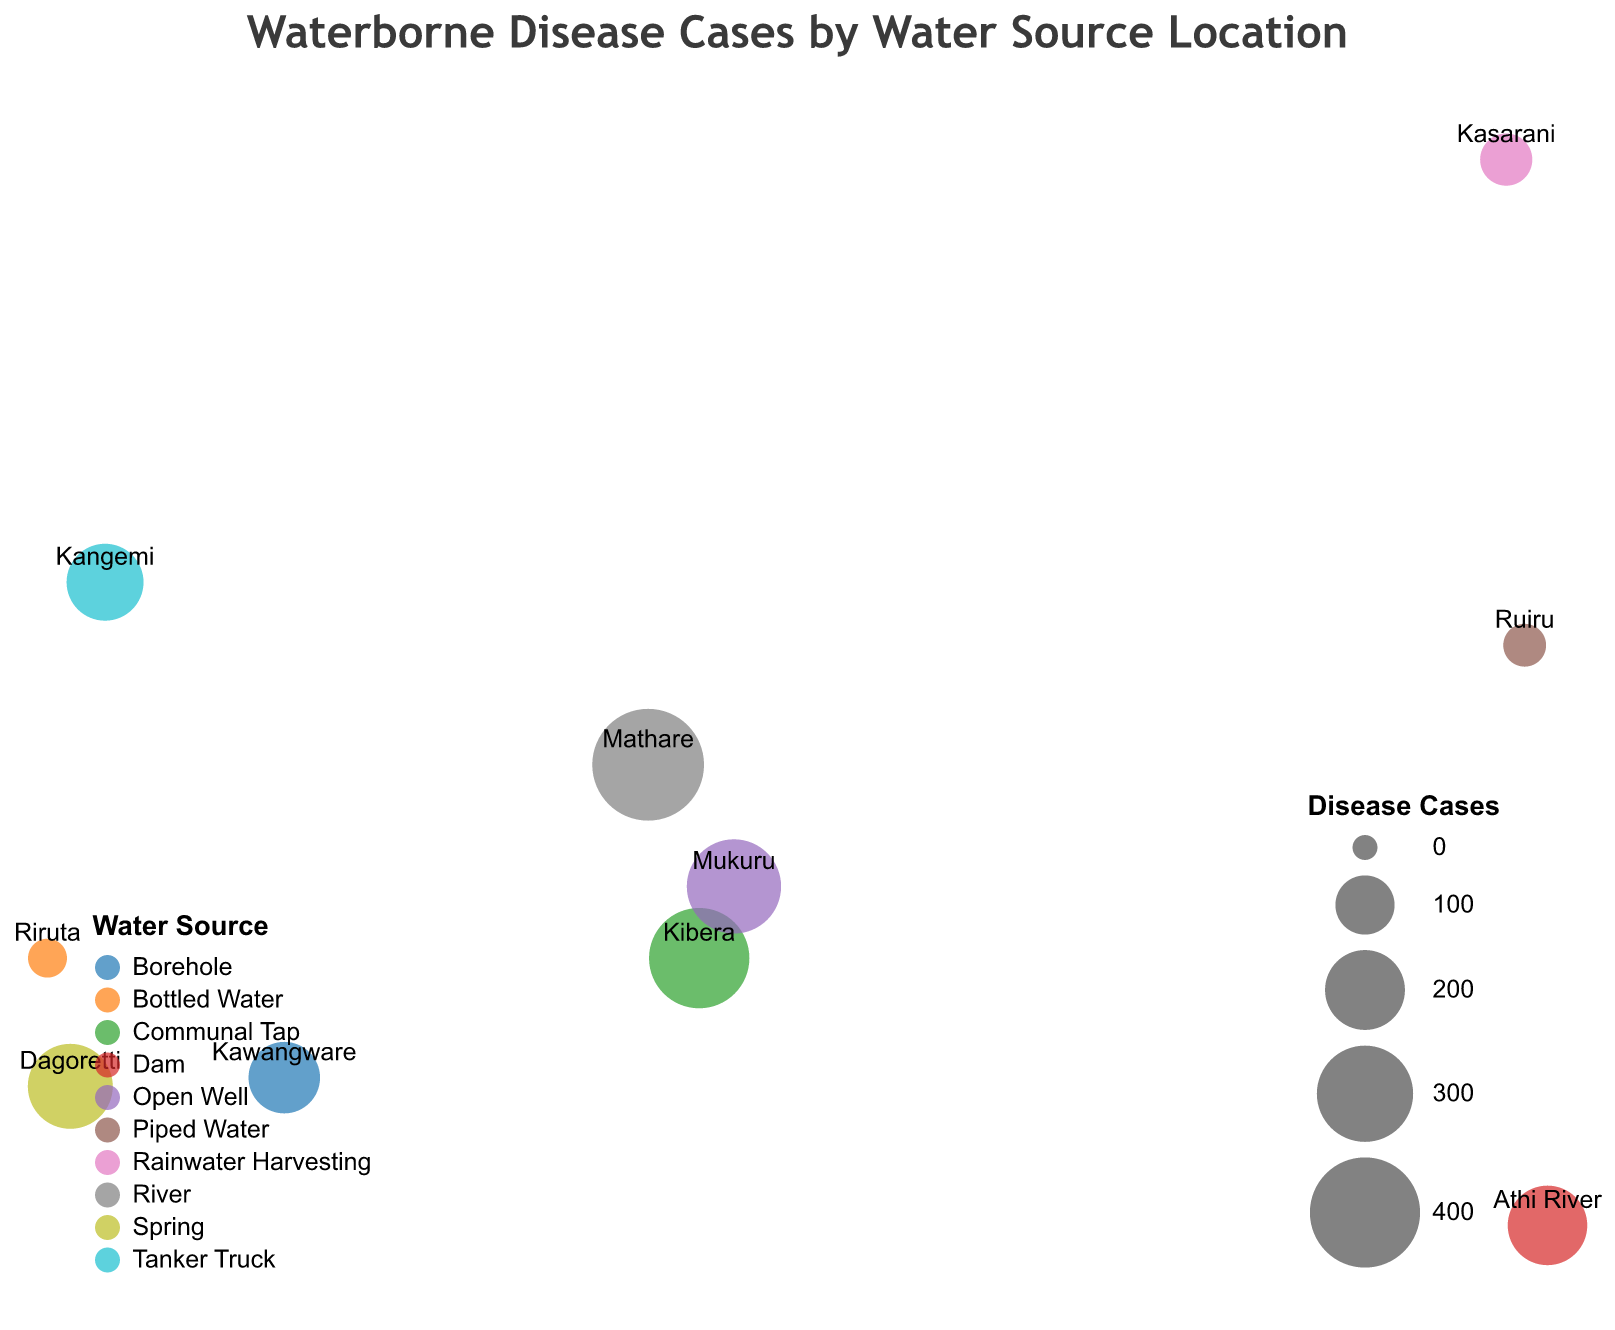How many locations are shown in the figure? The title of the figure suggests that each circle represents a location. By counting the circles on the map, we determine the number of locations.
Answer: 10 Which water source has the highest number of waterborne disease cases? Each water source is represented by a different color. By looking at the color with the largest size circle, we find that "River" (Mathare) has the highest number of cases (412).
Answer: River Where is the location with the least number of waterborne disease cases, and what is its water source? By identifying the smallest circle size on the map, we find the location. The smallest circle corresponds to Riruta with 31 cases, using Bottled Water.
Answer: Riruta, Bottled Water Compare the waterborne disease cases between Kibera and Mukuru. Find the circles for Kibera and Mukuru, then compare their sizes. Kibera has 328 cases, and Mukuru has 287 cases.
Answer: Kibera has more cases than Mukuru What is the average number of waterborne disease cases for locations using a natural water source (River, Dam, or Spring)? Sum the number of cases for each natural water source: River (412), Dam (198), and Spring (229). Then, divide by the number of relevant locations. Calculation: (412 + 198 + 229) / 3 = 279.67
Answer: 279.67 Which location has the highest population and what is its water source? Check the tooltip data for population values. Identify Ruiru as the location with the highest population (150,000) and its water source is Piped Water.
Answer: Ruiru, Piped Water What is the total population covered by the study? Sum up the population for all locations. Calculation: 250000 + 180000 + 110000 + 100000 + 150000 + 80000 + 90000 + 130000 + 100000 + 70000 = 1165000
Answer: 1,165,000 Is there a correlation between population size and waterborne disease cases? By analyzing the figure, check if larger populations tend to have more or fewer disease cases. Locations with larger populations like Ruiru (150,000) have relatively fewer cases (42), indicating a possible negative correlation.
Answer: There appears to be a negative correlation Which water source has the highest diversity in disease case numbers across its locations? Compare the range (difference between the highest and lowest values) of disease cases for each water source. For example: Natural water sources (River, Dam, Spring) have cases ranging from 198 to 412.
Answer: Natural water sources (River, Dam, Spring) What type of geographic projection is used in the figure? The figure’s code or legend mentions the projection type. It uses a Mercator projection.
Answer: Mercator 